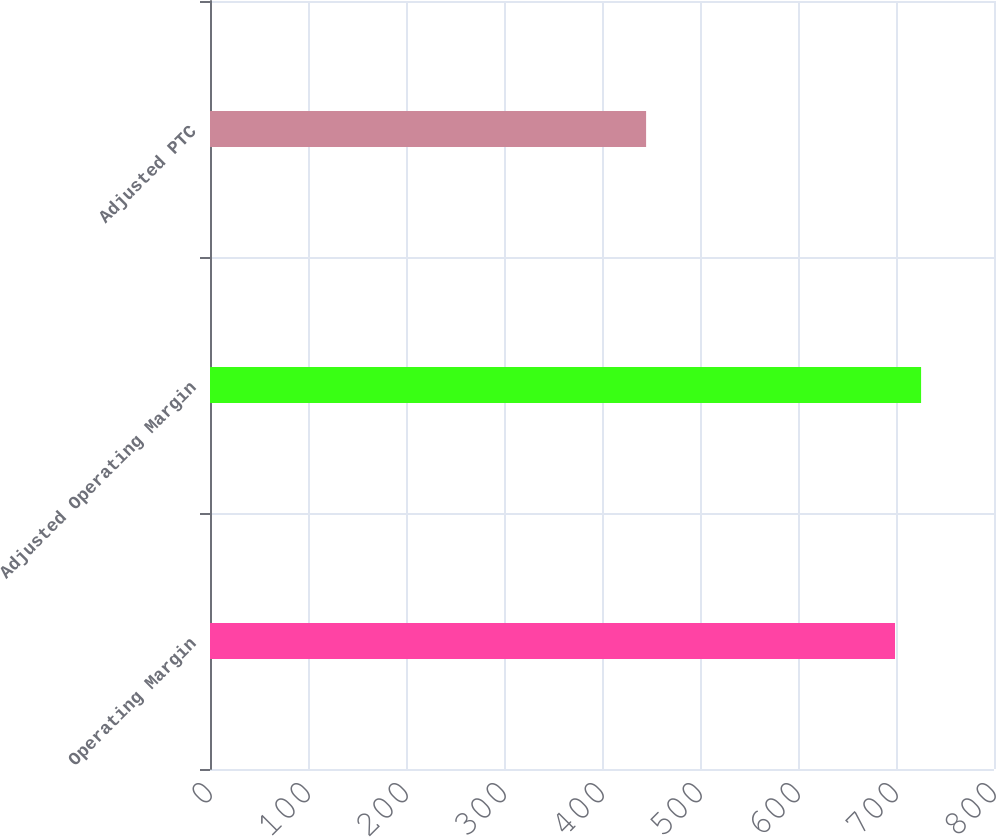Convert chart. <chart><loc_0><loc_0><loc_500><loc_500><bar_chart><fcel>Operating Margin<fcel>Adjusted Operating Margin<fcel>Adjusted PTC<nl><fcel>699<fcel>725.6<fcel>445<nl></chart> 